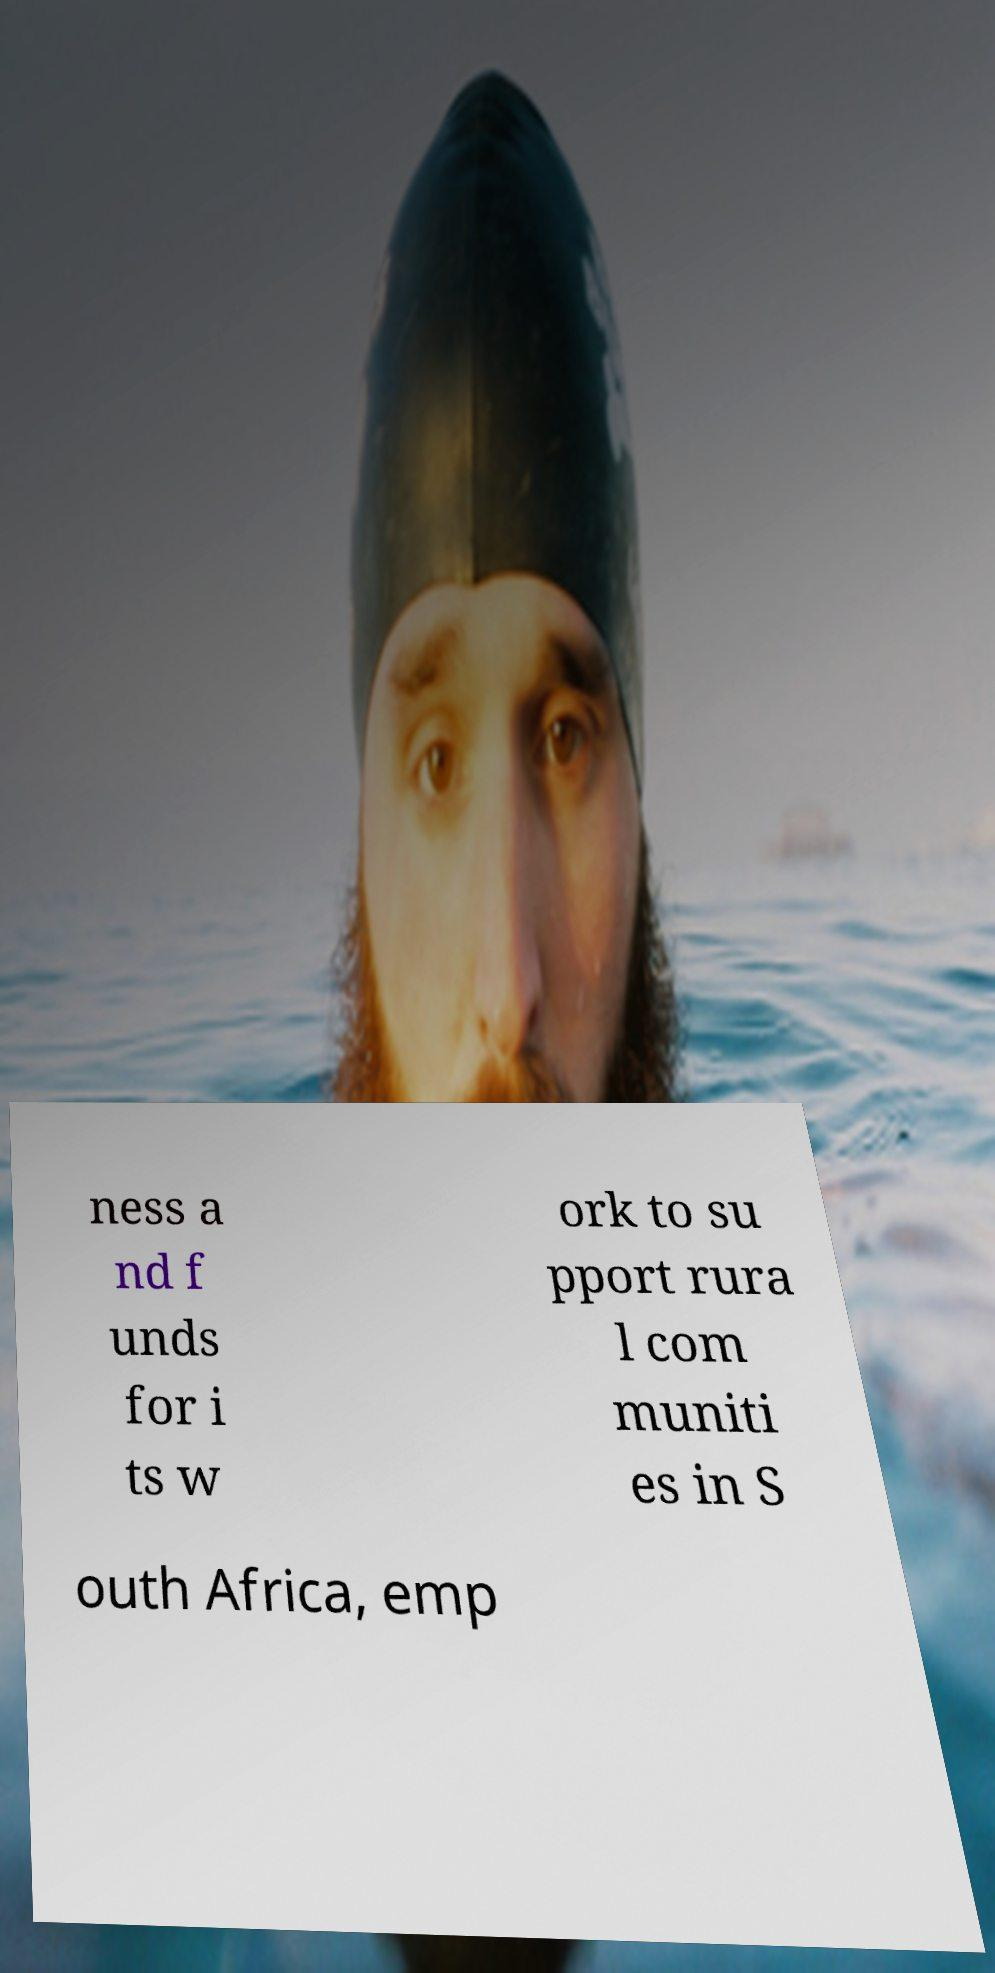Please identify and transcribe the text found in this image. ness a nd f unds for i ts w ork to su pport rura l com muniti es in S outh Africa, emp 